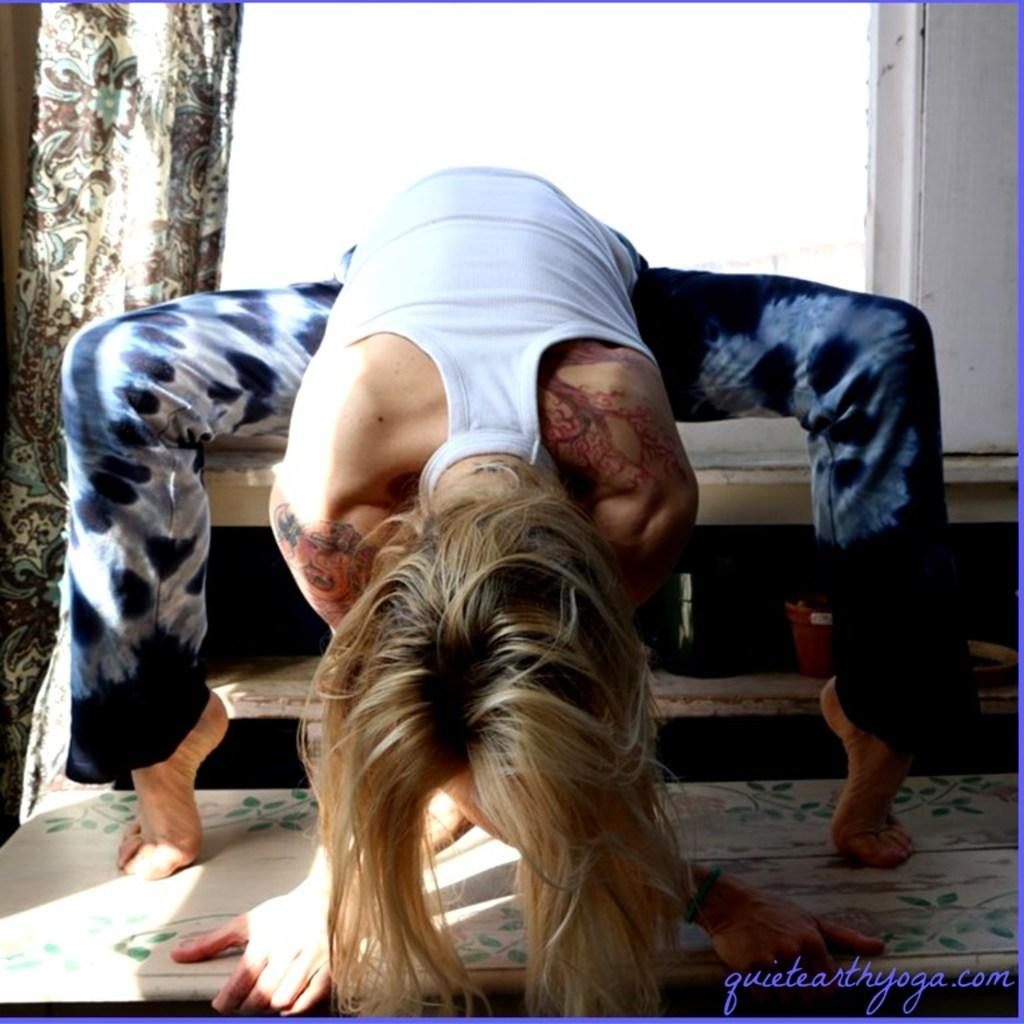What is the main subject in the image? There is a person sitting in the middle of the image. What can be seen behind the person? There is a wall behind the person. Is there any window treatment associated with the wall? Yes, there is a curtain associated with the wall. What type of turkey is being served in the image? There is no turkey present in the image; it features a person sitting in front of a wall with a curtain. What type of harmony is being displayed by the person in the image? The image does not depict any specific type of harmony; it simply shows a person sitting in front of a wall with a curtain. 